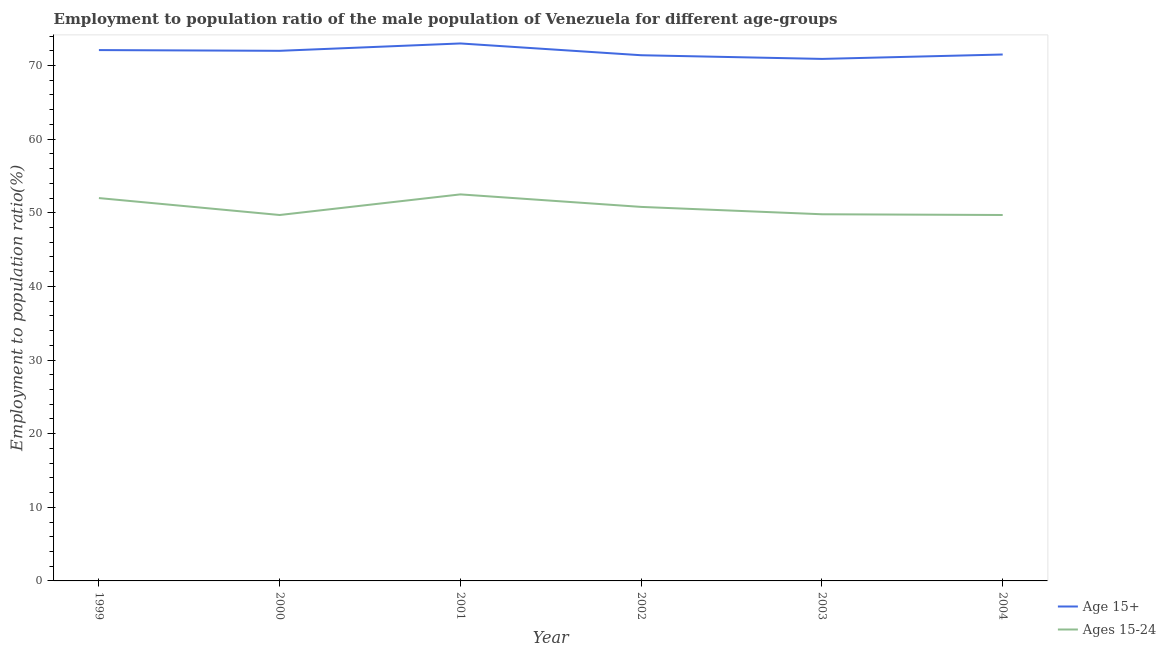How many different coloured lines are there?
Ensure brevity in your answer.  2. Does the line corresponding to employment to population ratio(age 15-24) intersect with the line corresponding to employment to population ratio(age 15+)?
Offer a very short reply. No. Is the number of lines equal to the number of legend labels?
Give a very brief answer. Yes. What is the employment to population ratio(age 15-24) in 2002?
Keep it short and to the point. 50.8. Across all years, what is the maximum employment to population ratio(age 15-24)?
Keep it short and to the point. 52.5. Across all years, what is the minimum employment to population ratio(age 15+)?
Your answer should be compact. 70.9. In which year was the employment to population ratio(age 15-24) maximum?
Make the answer very short. 2001. What is the total employment to population ratio(age 15+) in the graph?
Ensure brevity in your answer.  430.9. What is the difference between the employment to population ratio(age 15-24) in 2001 and that in 2004?
Provide a succinct answer. 2.8. What is the difference between the employment to population ratio(age 15+) in 2003 and the employment to population ratio(age 15-24) in 2002?
Your response must be concise. 20.1. What is the average employment to population ratio(age 15-24) per year?
Keep it short and to the point. 50.75. In the year 2000, what is the difference between the employment to population ratio(age 15+) and employment to population ratio(age 15-24)?
Make the answer very short. 22.3. In how many years, is the employment to population ratio(age 15+) greater than 40 %?
Offer a very short reply. 6. What is the ratio of the employment to population ratio(age 15+) in 2001 to that in 2003?
Ensure brevity in your answer.  1.03. Is the difference between the employment to population ratio(age 15+) in 2001 and 2003 greater than the difference between the employment to population ratio(age 15-24) in 2001 and 2003?
Offer a terse response. No. What is the difference between the highest and the second highest employment to population ratio(age 15+)?
Give a very brief answer. 0.9. What is the difference between the highest and the lowest employment to population ratio(age 15+)?
Offer a terse response. 2.1. In how many years, is the employment to population ratio(age 15-24) greater than the average employment to population ratio(age 15-24) taken over all years?
Offer a very short reply. 3. Does the employment to population ratio(age 15+) monotonically increase over the years?
Ensure brevity in your answer.  No. How many lines are there?
Your answer should be very brief. 2. Are the values on the major ticks of Y-axis written in scientific E-notation?
Your answer should be very brief. No. Does the graph contain any zero values?
Provide a short and direct response. No. How many legend labels are there?
Ensure brevity in your answer.  2. How are the legend labels stacked?
Ensure brevity in your answer.  Vertical. What is the title of the graph?
Offer a very short reply. Employment to population ratio of the male population of Venezuela for different age-groups. What is the label or title of the X-axis?
Make the answer very short. Year. What is the Employment to population ratio(%) of Age 15+ in 1999?
Offer a terse response. 72.1. What is the Employment to population ratio(%) of Age 15+ in 2000?
Provide a succinct answer. 72. What is the Employment to population ratio(%) in Ages 15-24 in 2000?
Ensure brevity in your answer.  49.7. What is the Employment to population ratio(%) in Age 15+ in 2001?
Provide a short and direct response. 73. What is the Employment to population ratio(%) of Ages 15-24 in 2001?
Provide a short and direct response. 52.5. What is the Employment to population ratio(%) in Age 15+ in 2002?
Provide a short and direct response. 71.4. What is the Employment to population ratio(%) in Ages 15-24 in 2002?
Provide a succinct answer. 50.8. What is the Employment to population ratio(%) of Age 15+ in 2003?
Your answer should be very brief. 70.9. What is the Employment to population ratio(%) in Ages 15-24 in 2003?
Your answer should be very brief. 49.8. What is the Employment to population ratio(%) in Age 15+ in 2004?
Offer a terse response. 71.5. What is the Employment to population ratio(%) in Ages 15-24 in 2004?
Make the answer very short. 49.7. Across all years, what is the maximum Employment to population ratio(%) of Ages 15-24?
Provide a short and direct response. 52.5. Across all years, what is the minimum Employment to population ratio(%) in Age 15+?
Your response must be concise. 70.9. Across all years, what is the minimum Employment to population ratio(%) of Ages 15-24?
Offer a very short reply. 49.7. What is the total Employment to population ratio(%) in Age 15+ in the graph?
Offer a very short reply. 430.9. What is the total Employment to population ratio(%) of Ages 15-24 in the graph?
Give a very brief answer. 304.5. What is the difference between the Employment to population ratio(%) of Age 15+ in 1999 and that in 2002?
Keep it short and to the point. 0.7. What is the difference between the Employment to population ratio(%) of Ages 15-24 in 1999 and that in 2002?
Your answer should be compact. 1.2. What is the difference between the Employment to population ratio(%) in Ages 15-24 in 1999 and that in 2003?
Provide a succinct answer. 2.2. What is the difference between the Employment to population ratio(%) in Age 15+ in 1999 and that in 2004?
Provide a succinct answer. 0.6. What is the difference between the Employment to population ratio(%) in Ages 15-24 in 1999 and that in 2004?
Offer a terse response. 2.3. What is the difference between the Employment to population ratio(%) of Age 15+ in 2000 and that in 2001?
Provide a short and direct response. -1. What is the difference between the Employment to population ratio(%) in Ages 15-24 in 2000 and that in 2001?
Offer a very short reply. -2.8. What is the difference between the Employment to population ratio(%) of Ages 15-24 in 2000 and that in 2002?
Offer a terse response. -1.1. What is the difference between the Employment to population ratio(%) in Age 15+ in 2000 and that in 2003?
Make the answer very short. 1.1. What is the difference between the Employment to population ratio(%) of Ages 15-24 in 2001 and that in 2002?
Your answer should be compact. 1.7. What is the difference between the Employment to population ratio(%) in Age 15+ in 2001 and that in 2003?
Offer a very short reply. 2.1. What is the difference between the Employment to population ratio(%) of Ages 15-24 in 2001 and that in 2004?
Offer a terse response. 2.8. What is the difference between the Employment to population ratio(%) of Age 15+ in 2002 and that in 2003?
Provide a short and direct response. 0.5. What is the difference between the Employment to population ratio(%) of Ages 15-24 in 2002 and that in 2003?
Give a very brief answer. 1. What is the difference between the Employment to population ratio(%) in Age 15+ in 1999 and the Employment to population ratio(%) in Ages 15-24 in 2000?
Keep it short and to the point. 22.4. What is the difference between the Employment to population ratio(%) of Age 15+ in 1999 and the Employment to population ratio(%) of Ages 15-24 in 2001?
Give a very brief answer. 19.6. What is the difference between the Employment to population ratio(%) of Age 15+ in 1999 and the Employment to population ratio(%) of Ages 15-24 in 2002?
Offer a terse response. 21.3. What is the difference between the Employment to population ratio(%) in Age 15+ in 1999 and the Employment to population ratio(%) in Ages 15-24 in 2003?
Your answer should be very brief. 22.3. What is the difference between the Employment to population ratio(%) in Age 15+ in 1999 and the Employment to population ratio(%) in Ages 15-24 in 2004?
Offer a very short reply. 22.4. What is the difference between the Employment to population ratio(%) in Age 15+ in 2000 and the Employment to population ratio(%) in Ages 15-24 in 2002?
Your response must be concise. 21.2. What is the difference between the Employment to population ratio(%) in Age 15+ in 2000 and the Employment to population ratio(%) in Ages 15-24 in 2003?
Your answer should be compact. 22.2. What is the difference between the Employment to population ratio(%) in Age 15+ in 2000 and the Employment to population ratio(%) in Ages 15-24 in 2004?
Your response must be concise. 22.3. What is the difference between the Employment to population ratio(%) of Age 15+ in 2001 and the Employment to population ratio(%) of Ages 15-24 in 2002?
Your answer should be very brief. 22.2. What is the difference between the Employment to population ratio(%) of Age 15+ in 2001 and the Employment to population ratio(%) of Ages 15-24 in 2003?
Provide a succinct answer. 23.2. What is the difference between the Employment to population ratio(%) in Age 15+ in 2001 and the Employment to population ratio(%) in Ages 15-24 in 2004?
Your answer should be compact. 23.3. What is the difference between the Employment to population ratio(%) of Age 15+ in 2002 and the Employment to population ratio(%) of Ages 15-24 in 2003?
Give a very brief answer. 21.6. What is the difference between the Employment to population ratio(%) in Age 15+ in 2002 and the Employment to population ratio(%) in Ages 15-24 in 2004?
Offer a terse response. 21.7. What is the difference between the Employment to population ratio(%) in Age 15+ in 2003 and the Employment to population ratio(%) in Ages 15-24 in 2004?
Provide a short and direct response. 21.2. What is the average Employment to population ratio(%) of Age 15+ per year?
Your answer should be compact. 71.82. What is the average Employment to population ratio(%) of Ages 15-24 per year?
Your answer should be compact. 50.75. In the year 1999, what is the difference between the Employment to population ratio(%) in Age 15+ and Employment to population ratio(%) in Ages 15-24?
Offer a very short reply. 20.1. In the year 2000, what is the difference between the Employment to population ratio(%) in Age 15+ and Employment to population ratio(%) in Ages 15-24?
Ensure brevity in your answer.  22.3. In the year 2001, what is the difference between the Employment to population ratio(%) in Age 15+ and Employment to population ratio(%) in Ages 15-24?
Your answer should be very brief. 20.5. In the year 2002, what is the difference between the Employment to population ratio(%) of Age 15+ and Employment to population ratio(%) of Ages 15-24?
Your response must be concise. 20.6. In the year 2003, what is the difference between the Employment to population ratio(%) in Age 15+ and Employment to population ratio(%) in Ages 15-24?
Your answer should be compact. 21.1. In the year 2004, what is the difference between the Employment to population ratio(%) in Age 15+ and Employment to population ratio(%) in Ages 15-24?
Make the answer very short. 21.8. What is the ratio of the Employment to population ratio(%) in Ages 15-24 in 1999 to that in 2000?
Give a very brief answer. 1.05. What is the ratio of the Employment to population ratio(%) of Age 15+ in 1999 to that in 2001?
Give a very brief answer. 0.99. What is the ratio of the Employment to population ratio(%) in Ages 15-24 in 1999 to that in 2001?
Make the answer very short. 0.99. What is the ratio of the Employment to population ratio(%) of Age 15+ in 1999 to that in 2002?
Make the answer very short. 1.01. What is the ratio of the Employment to population ratio(%) of Ages 15-24 in 1999 to that in 2002?
Give a very brief answer. 1.02. What is the ratio of the Employment to population ratio(%) of Age 15+ in 1999 to that in 2003?
Offer a terse response. 1.02. What is the ratio of the Employment to population ratio(%) of Ages 15-24 in 1999 to that in 2003?
Offer a terse response. 1.04. What is the ratio of the Employment to population ratio(%) of Age 15+ in 1999 to that in 2004?
Make the answer very short. 1.01. What is the ratio of the Employment to population ratio(%) of Ages 15-24 in 1999 to that in 2004?
Make the answer very short. 1.05. What is the ratio of the Employment to population ratio(%) in Age 15+ in 2000 to that in 2001?
Offer a terse response. 0.99. What is the ratio of the Employment to population ratio(%) in Ages 15-24 in 2000 to that in 2001?
Your answer should be compact. 0.95. What is the ratio of the Employment to population ratio(%) of Age 15+ in 2000 to that in 2002?
Give a very brief answer. 1.01. What is the ratio of the Employment to population ratio(%) in Ages 15-24 in 2000 to that in 2002?
Give a very brief answer. 0.98. What is the ratio of the Employment to population ratio(%) in Age 15+ in 2000 to that in 2003?
Offer a terse response. 1.02. What is the ratio of the Employment to population ratio(%) in Age 15+ in 2000 to that in 2004?
Provide a succinct answer. 1.01. What is the ratio of the Employment to population ratio(%) of Age 15+ in 2001 to that in 2002?
Your answer should be compact. 1.02. What is the ratio of the Employment to population ratio(%) in Ages 15-24 in 2001 to that in 2002?
Give a very brief answer. 1.03. What is the ratio of the Employment to population ratio(%) of Age 15+ in 2001 to that in 2003?
Your answer should be very brief. 1.03. What is the ratio of the Employment to population ratio(%) of Ages 15-24 in 2001 to that in 2003?
Make the answer very short. 1.05. What is the ratio of the Employment to population ratio(%) of Ages 15-24 in 2001 to that in 2004?
Offer a terse response. 1.06. What is the ratio of the Employment to population ratio(%) of Age 15+ in 2002 to that in 2003?
Your response must be concise. 1.01. What is the ratio of the Employment to population ratio(%) of Ages 15-24 in 2002 to that in 2003?
Your answer should be very brief. 1.02. What is the ratio of the Employment to population ratio(%) of Age 15+ in 2002 to that in 2004?
Ensure brevity in your answer.  1. What is the ratio of the Employment to population ratio(%) in Ages 15-24 in 2002 to that in 2004?
Provide a short and direct response. 1.02. What is the difference between the highest and the second highest Employment to population ratio(%) in Ages 15-24?
Offer a very short reply. 0.5. What is the difference between the highest and the lowest Employment to population ratio(%) of Age 15+?
Your response must be concise. 2.1. 